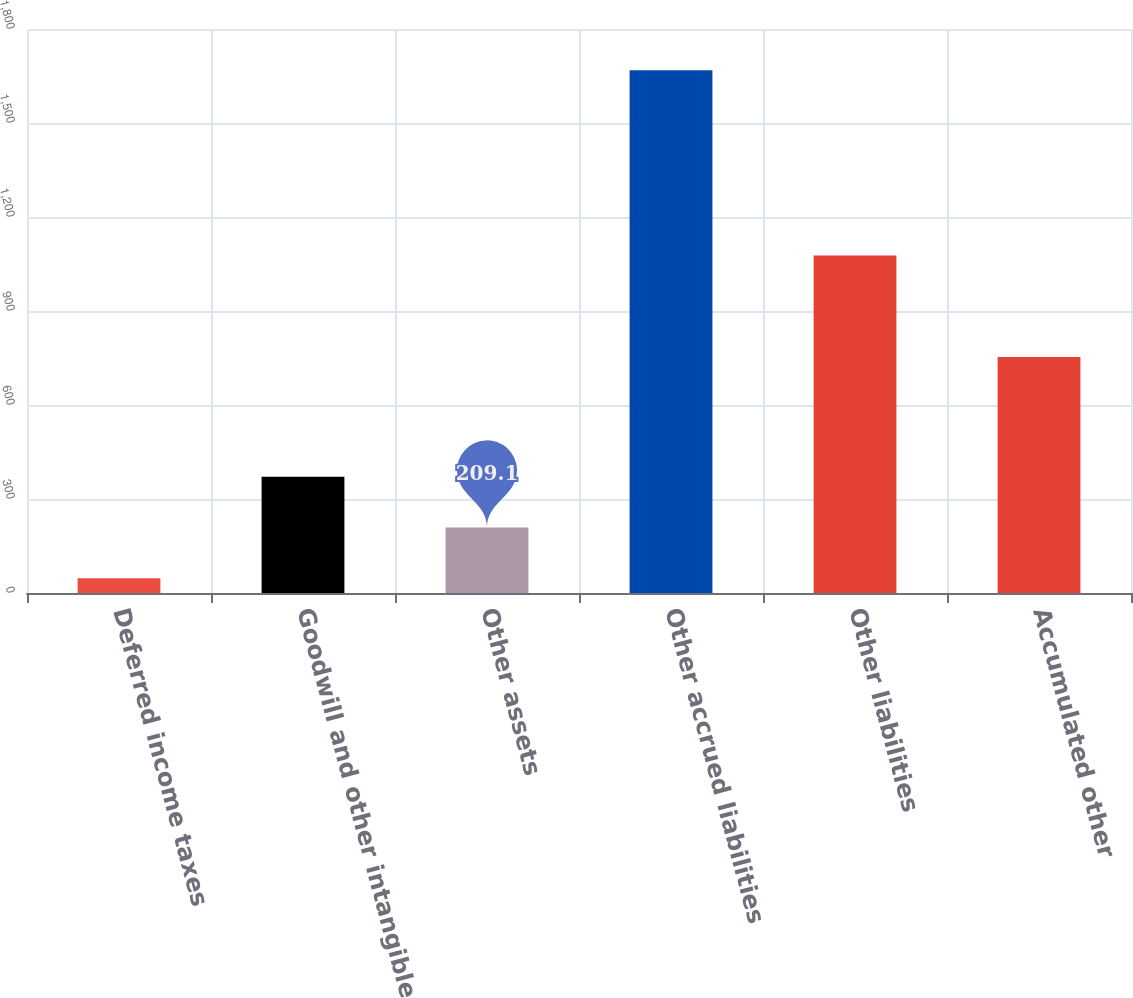Convert chart to OTSL. <chart><loc_0><loc_0><loc_500><loc_500><bar_chart><fcel>Deferred income taxes<fcel>Goodwill and other intangible<fcel>Other assets<fcel>Other accrued liabilities<fcel>Other liabilities<fcel>Accumulated other<nl><fcel>47<fcel>371.2<fcel>209.1<fcel>1668<fcel>1077.2<fcel>753<nl></chart> 